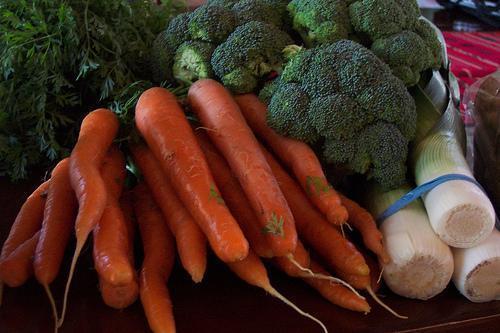How many types of vegetables are shown?
Give a very brief answer. 4. 